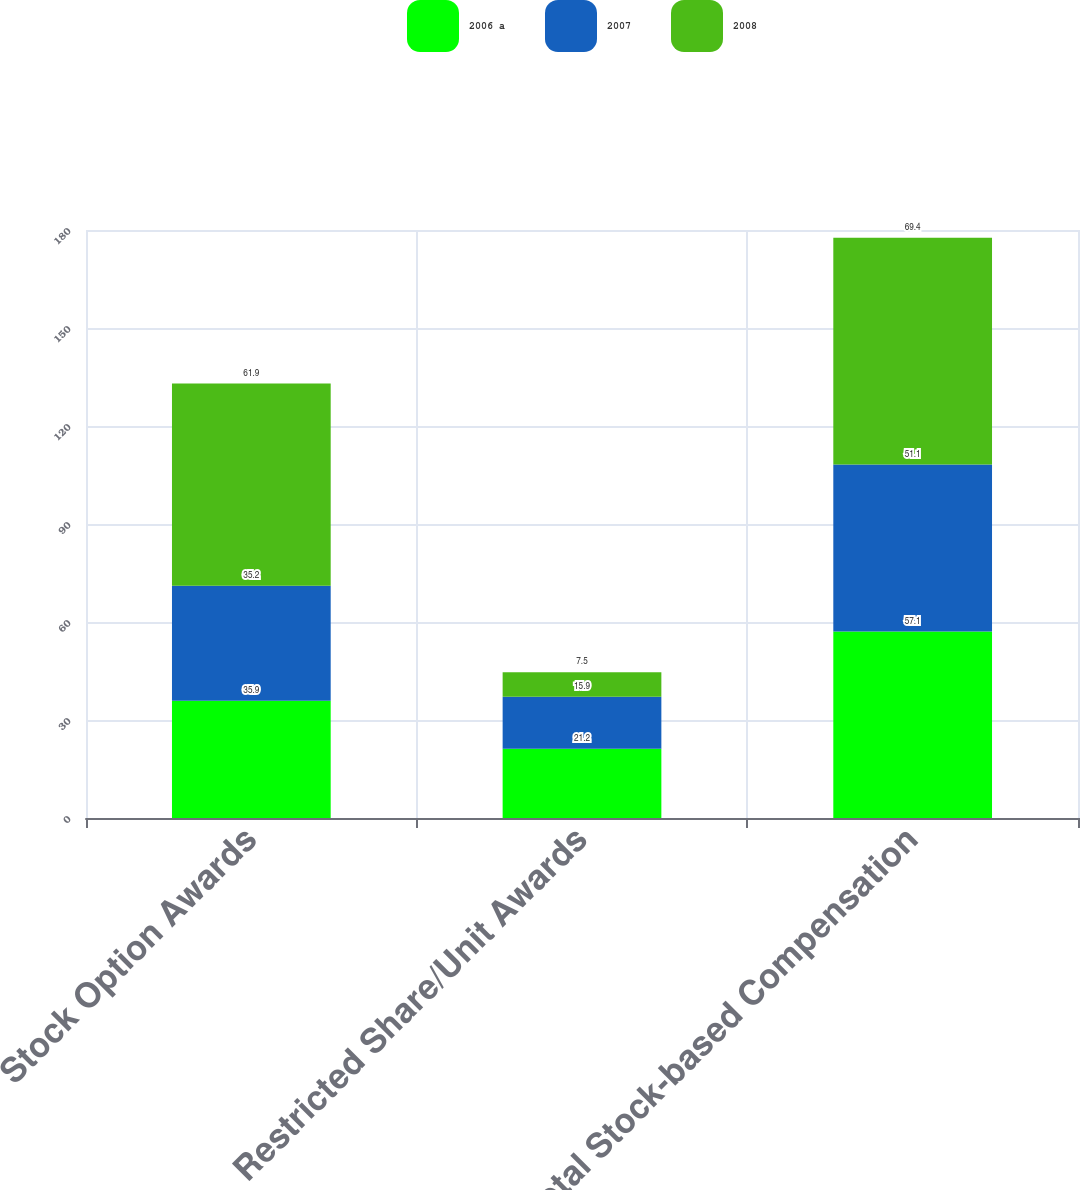Convert chart. <chart><loc_0><loc_0><loc_500><loc_500><stacked_bar_chart><ecel><fcel>Stock Option Awards<fcel>Restricted Share/Unit Awards<fcel>Total Stock-based Compensation<nl><fcel>2006 a<fcel>35.9<fcel>21.2<fcel>57.1<nl><fcel>2007<fcel>35.2<fcel>15.9<fcel>51.1<nl><fcel>2008<fcel>61.9<fcel>7.5<fcel>69.4<nl></chart> 